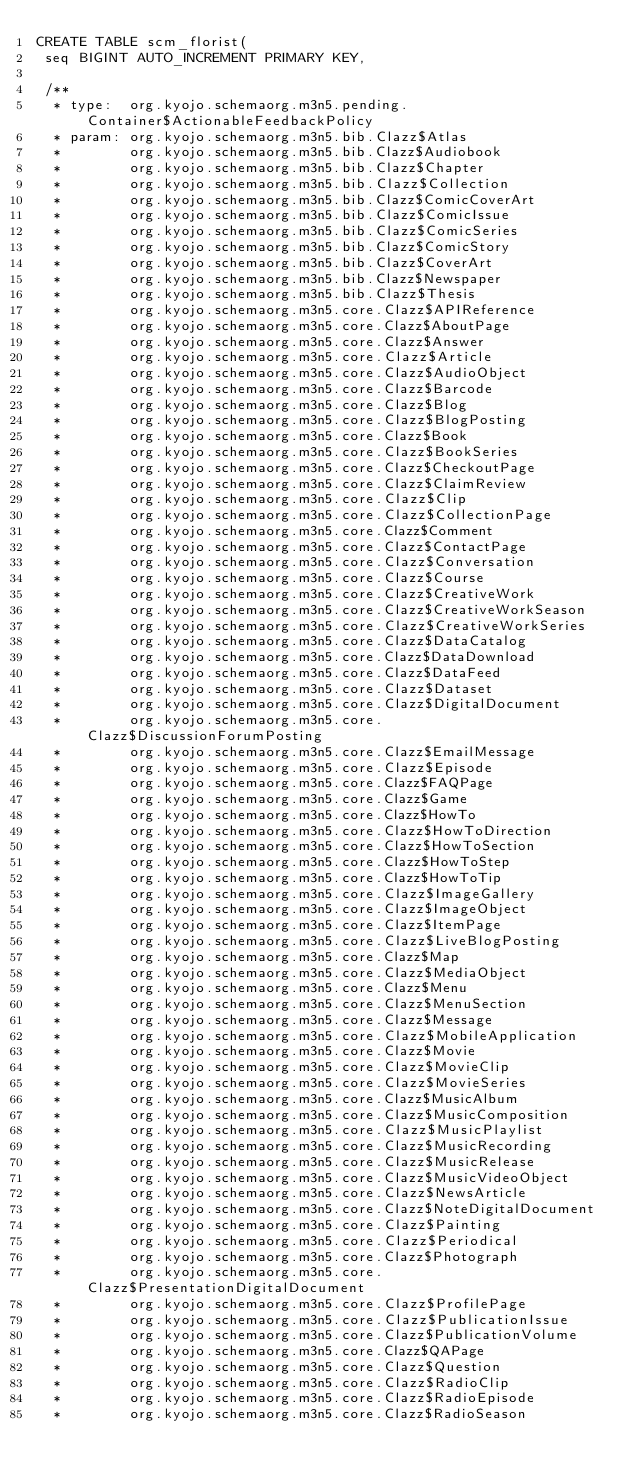Convert code to text. <code><loc_0><loc_0><loc_500><loc_500><_SQL_>CREATE TABLE scm_florist(
 seq BIGINT AUTO_INCREMENT PRIMARY KEY,

 /**
  * type:  org.kyojo.schemaorg.m3n5.pending.Container$ActionableFeedbackPolicy
  * param: org.kyojo.schemaorg.m3n5.bib.Clazz$Atlas
  *        org.kyojo.schemaorg.m3n5.bib.Clazz$Audiobook
  *        org.kyojo.schemaorg.m3n5.bib.Clazz$Chapter
  *        org.kyojo.schemaorg.m3n5.bib.Clazz$Collection
  *        org.kyojo.schemaorg.m3n5.bib.Clazz$ComicCoverArt
  *        org.kyojo.schemaorg.m3n5.bib.Clazz$ComicIssue
  *        org.kyojo.schemaorg.m3n5.bib.Clazz$ComicSeries
  *        org.kyojo.schemaorg.m3n5.bib.Clazz$ComicStory
  *        org.kyojo.schemaorg.m3n5.bib.Clazz$CoverArt
  *        org.kyojo.schemaorg.m3n5.bib.Clazz$Newspaper
  *        org.kyojo.schemaorg.m3n5.bib.Clazz$Thesis
  *        org.kyojo.schemaorg.m3n5.core.Clazz$APIReference
  *        org.kyojo.schemaorg.m3n5.core.Clazz$AboutPage
  *        org.kyojo.schemaorg.m3n5.core.Clazz$Answer
  *        org.kyojo.schemaorg.m3n5.core.Clazz$Article
  *        org.kyojo.schemaorg.m3n5.core.Clazz$AudioObject
  *        org.kyojo.schemaorg.m3n5.core.Clazz$Barcode
  *        org.kyojo.schemaorg.m3n5.core.Clazz$Blog
  *        org.kyojo.schemaorg.m3n5.core.Clazz$BlogPosting
  *        org.kyojo.schemaorg.m3n5.core.Clazz$Book
  *        org.kyojo.schemaorg.m3n5.core.Clazz$BookSeries
  *        org.kyojo.schemaorg.m3n5.core.Clazz$CheckoutPage
  *        org.kyojo.schemaorg.m3n5.core.Clazz$ClaimReview
  *        org.kyojo.schemaorg.m3n5.core.Clazz$Clip
  *        org.kyojo.schemaorg.m3n5.core.Clazz$CollectionPage
  *        org.kyojo.schemaorg.m3n5.core.Clazz$Comment
  *        org.kyojo.schemaorg.m3n5.core.Clazz$ContactPage
  *        org.kyojo.schemaorg.m3n5.core.Clazz$Conversation
  *        org.kyojo.schemaorg.m3n5.core.Clazz$Course
  *        org.kyojo.schemaorg.m3n5.core.Clazz$CreativeWork
  *        org.kyojo.schemaorg.m3n5.core.Clazz$CreativeWorkSeason
  *        org.kyojo.schemaorg.m3n5.core.Clazz$CreativeWorkSeries
  *        org.kyojo.schemaorg.m3n5.core.Clazz$DataCatalog
  *        org.kyojo.schemaorg.m3n5.core.Clazz$DataDownload
  *        org.kyojo.schemaorg.m3n5.core.Clazz$DataFeed
  *        org.kyojo.schemaorg.m3n5.core.Clazz$Dataset
  *        org.kyojo.schemaorg.m3n5.core.Clazz$DigitalDocument
  *        org.kyojo.schemaorg.m3n5.core.Clazz$DiscussionForumPosting
  *        org.kyojo.schemaorg.m3n5.core.Clazz$EmailMessage
  *        org.kyojo.schemaorg.m3n5.core.Clazz$Episode
  *        org.kyojo.schemaorg.m3n5.core.Clazz$FAQPage
  *        org.kyojo.schemaorg.m3n5.core.Clazz$Game
  *        org.kyojo.schemaorg.m3n5.core.Clazz$HowTo
  *        org.kyojo.schemaorg.m3n5.core.Clazz$HowToDirection
  *        org.kyojo.schemaorg.m3n5.core.Clazz$HowToSection
  *        org.kyojo.schemaorg.m3n5.core.Clazz$HowToStep
  *        org.kyojo.schemaorg.m3n5.core.Clazz$HowToTip
  *        org.kyojo.schemaorg.m3n5.core.Clazz$ImageGallery
  *        org.kyojo.schemaorg.m3n5.core.Clazz$ImageObject
  *        org.kyojo.schemaorg.m3n5.core.Clazz$ItemPage
  *        org.kyojo.schemaorg.m3n5.core.Clazz$LiveBlogPosting
  *        org.kyojo.schemaorg.m3n5.core.Clazz$Map
  *        org.kyojo.schemaorg.m3n5.core.Clazz$MediaObject
  *        org.kyojo.schemaorg.m3n5.core.Clazz$Menu
  *        org.kyojo.schemaorg.m3n5.core.Clazz$MenuSection
  *        org.kyojo.schemaorg.m3n5.core.Clazz$Message
  *        org.kyojo.schemaorg.m3n5.core.Clazz$MobileApplication
  *        org.kyojo.schemaorg.m3n5.core.Clazz$Movie
  *        org.kyojo.schemaorg.m3n5.core.Clazz$MovieClip
  *        org.kyojo.schemaorg.m3n5.core.Clazz$MovieSeries
  *        org.kyojo.schemaorg.m3n5.core.Clazz$MusicAlbum
  *        org.kyojo.schemaorg.m3n5.core.Clazz$MusicComposition
  *        org.kyojo.schemaorg.m3n5.core.Clazz$MusicPlaylist
  *        org.kyojo.schemaorg.m3n5.core.Clazz$MusicRecording
  *        org.kyojo.schemaorg.m3n5.core.Clazz$MusicRelease
  *        org.kyojo.schemaorg.m3n5.core.Clazz$MusicVideoObject
  *        org.kyojo.schemaorg.m3n5.core.Clazz$NewsArticle
  *        org.kyojo.schemaorg.m3n5.core.Clazz$NoteDigitalDocument
  *        org.kyojo.schemaorg.m3n5.core.Clazz$Painting
  *        org.kyojo.schemaorg.m3n5.core.Clazz$Periodical
  *        org.kyojo.schemaorg.m3n5.core.Clazz$Photograph
  *        org.kyojo.schemaorg.m3n5.core.Clazz$PresentationDigitalDocument
  *        org.kyojo.schemaorg.m3n5.core.Clazz$ProfilePage
  *        org.kyojo.schemaorg.m3n5.core.Clazz$PublicationIssue
  *        org.kyojo.schemaorg.m3n5.core.Clazz$PublicationVolume
  *        org.kyojo.schemaorg.m3n5.core.Clazz$QAPage
  *        org.kyojo.schemaorg.m3n5.core.Clazz$Question
  *        org.kyojo.schemaorg.m3n5.core.Clazz$RadioClip
  *        org.kyojo.schemaorg.m3n5.core.Clazz$RadioEpisode
  *        org.kyojo.schemaorg.m3n5.core.Clazz$RadioSeason</code> 